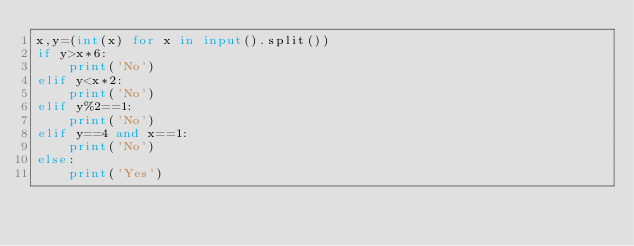<code> <loc_0><loc_0><loc_500><loc_500><_Python_>x,y=(int(x) for x in input().split())
if y>x*6:
    print('No')
elif y<x*2:
    print('No')
elif y%2==1:
    print('No')
elif y==4 and x==1:
    print('No')
else:
    print('Yes')
</code> 